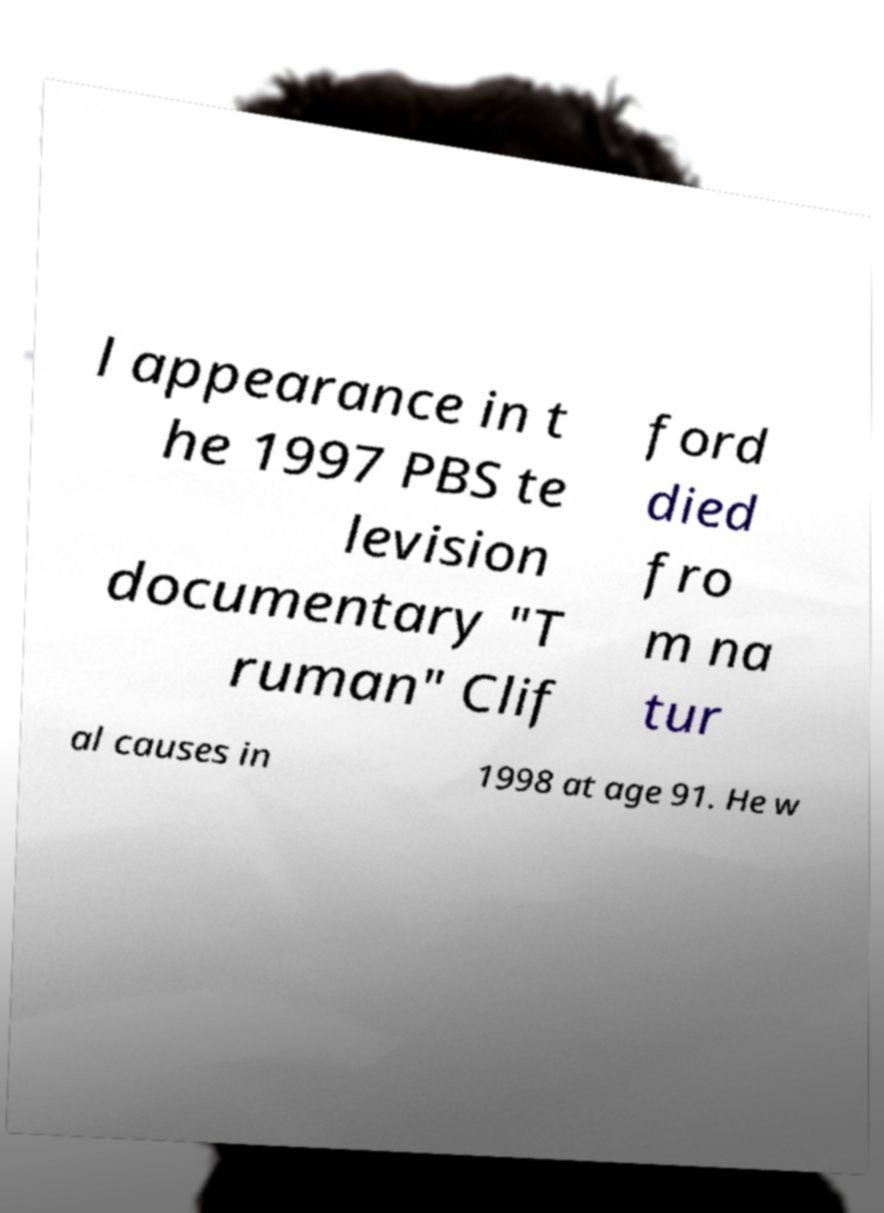Can you read and provide the text displayed in the image?This photo seems to have some interesting text. Can you extract and type it out for me? l appearance in t he 1997 PBS te levision documentary "T ruman" Clif ford died fro m na tur al causes in 1998 at age 91. He w 